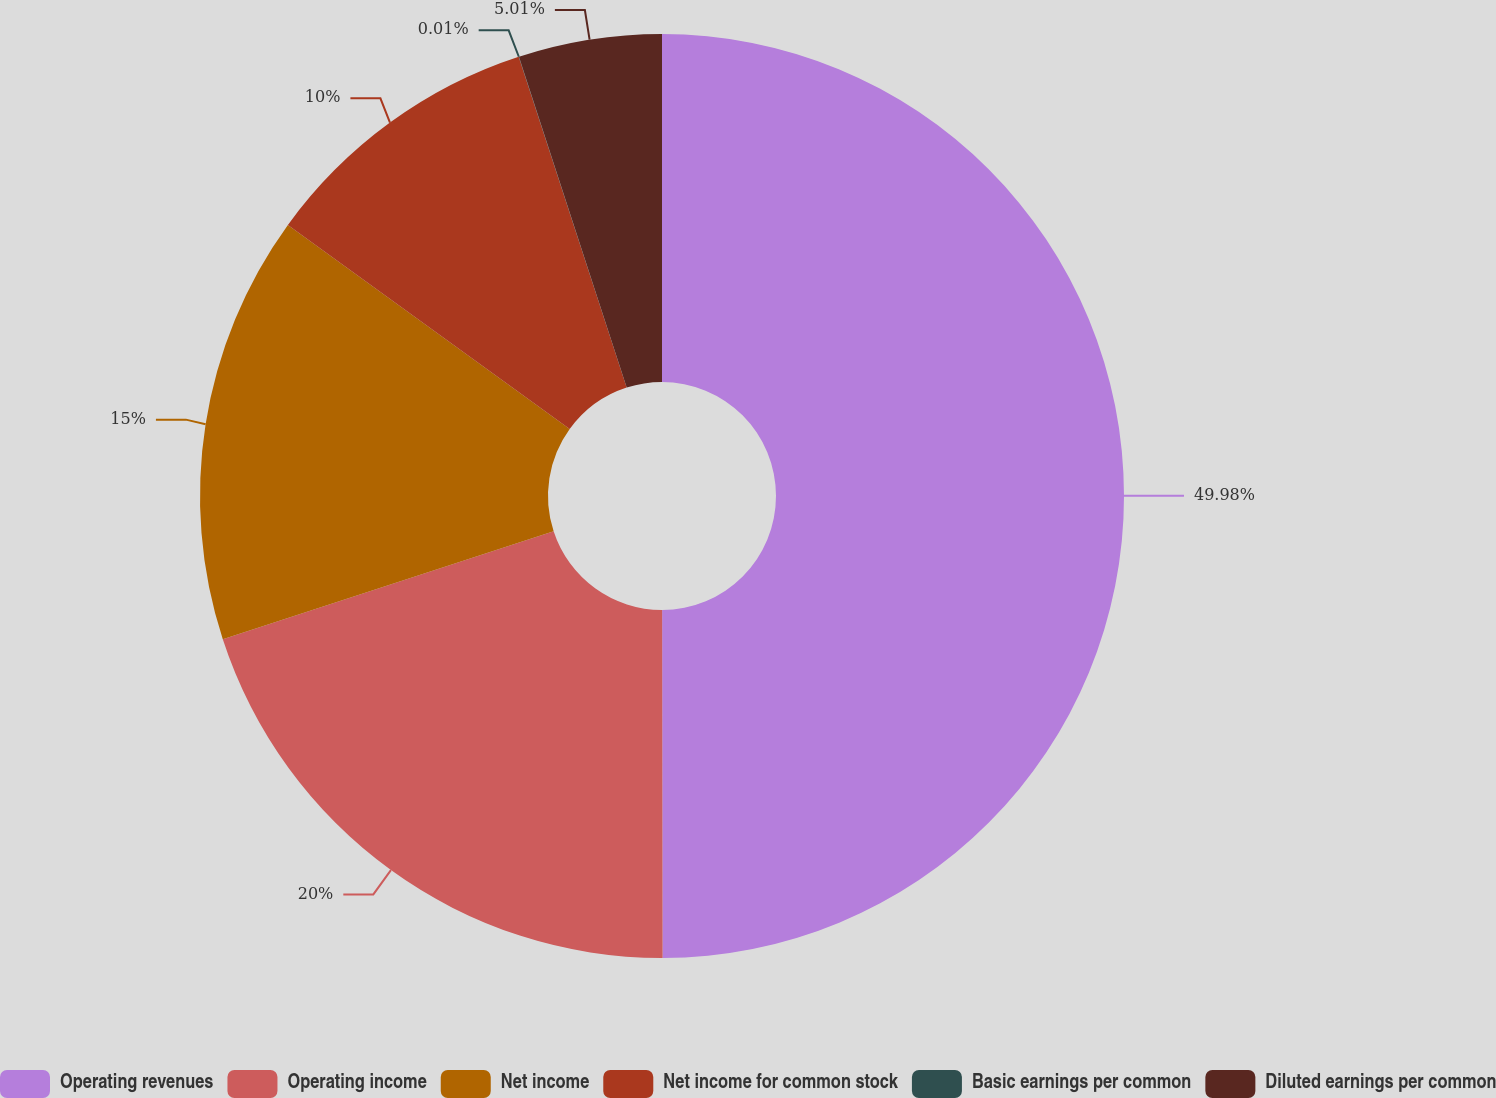Convert chart to OTSL. <chart><loc_0><loc_0><loc_500><loc_500><pie_chart><fcel>Operating revenues<fcel>Operating income<fcel>Net income<fcel>Net income for common stock<fcel>Basic earnings per common<fcel>Diluted earnings per common<nl><fcel>49.98%<fcel>20.0%<fcel>15.0%<fcel>10.0%<fcel>0.01%<fcel>5.01%<nl></chart> 